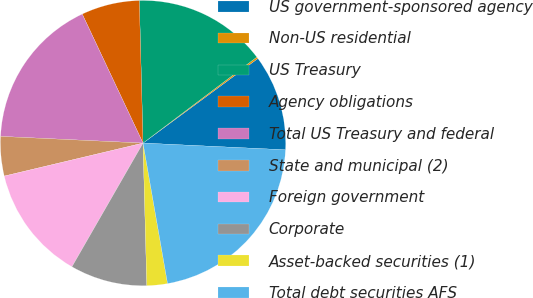Convert chart. <chart><loc_0><loc_0><loc_500><loc_500><pie_chart><fcel>US government-sponsored agency<fcel>Non-US residential<fcel>US Treasury<fcel>Agency obligations<fcel>Total US Treasury and federal<fcel>State and municipal (2)<fcel>Foreign government<fcel>Corporate<fcel>Asset-backed securities (1)<fcel>Total debt securities AFS<nl><fcel>10.85%<fcel>0.2%<fcel>15.11%<fcel>6.59%<fcel>17.24%<fcel>4.46%<fcel>12.98%<fcel>8.72%<fcel>2.33%<fcel>21.49%<nl></chart> 